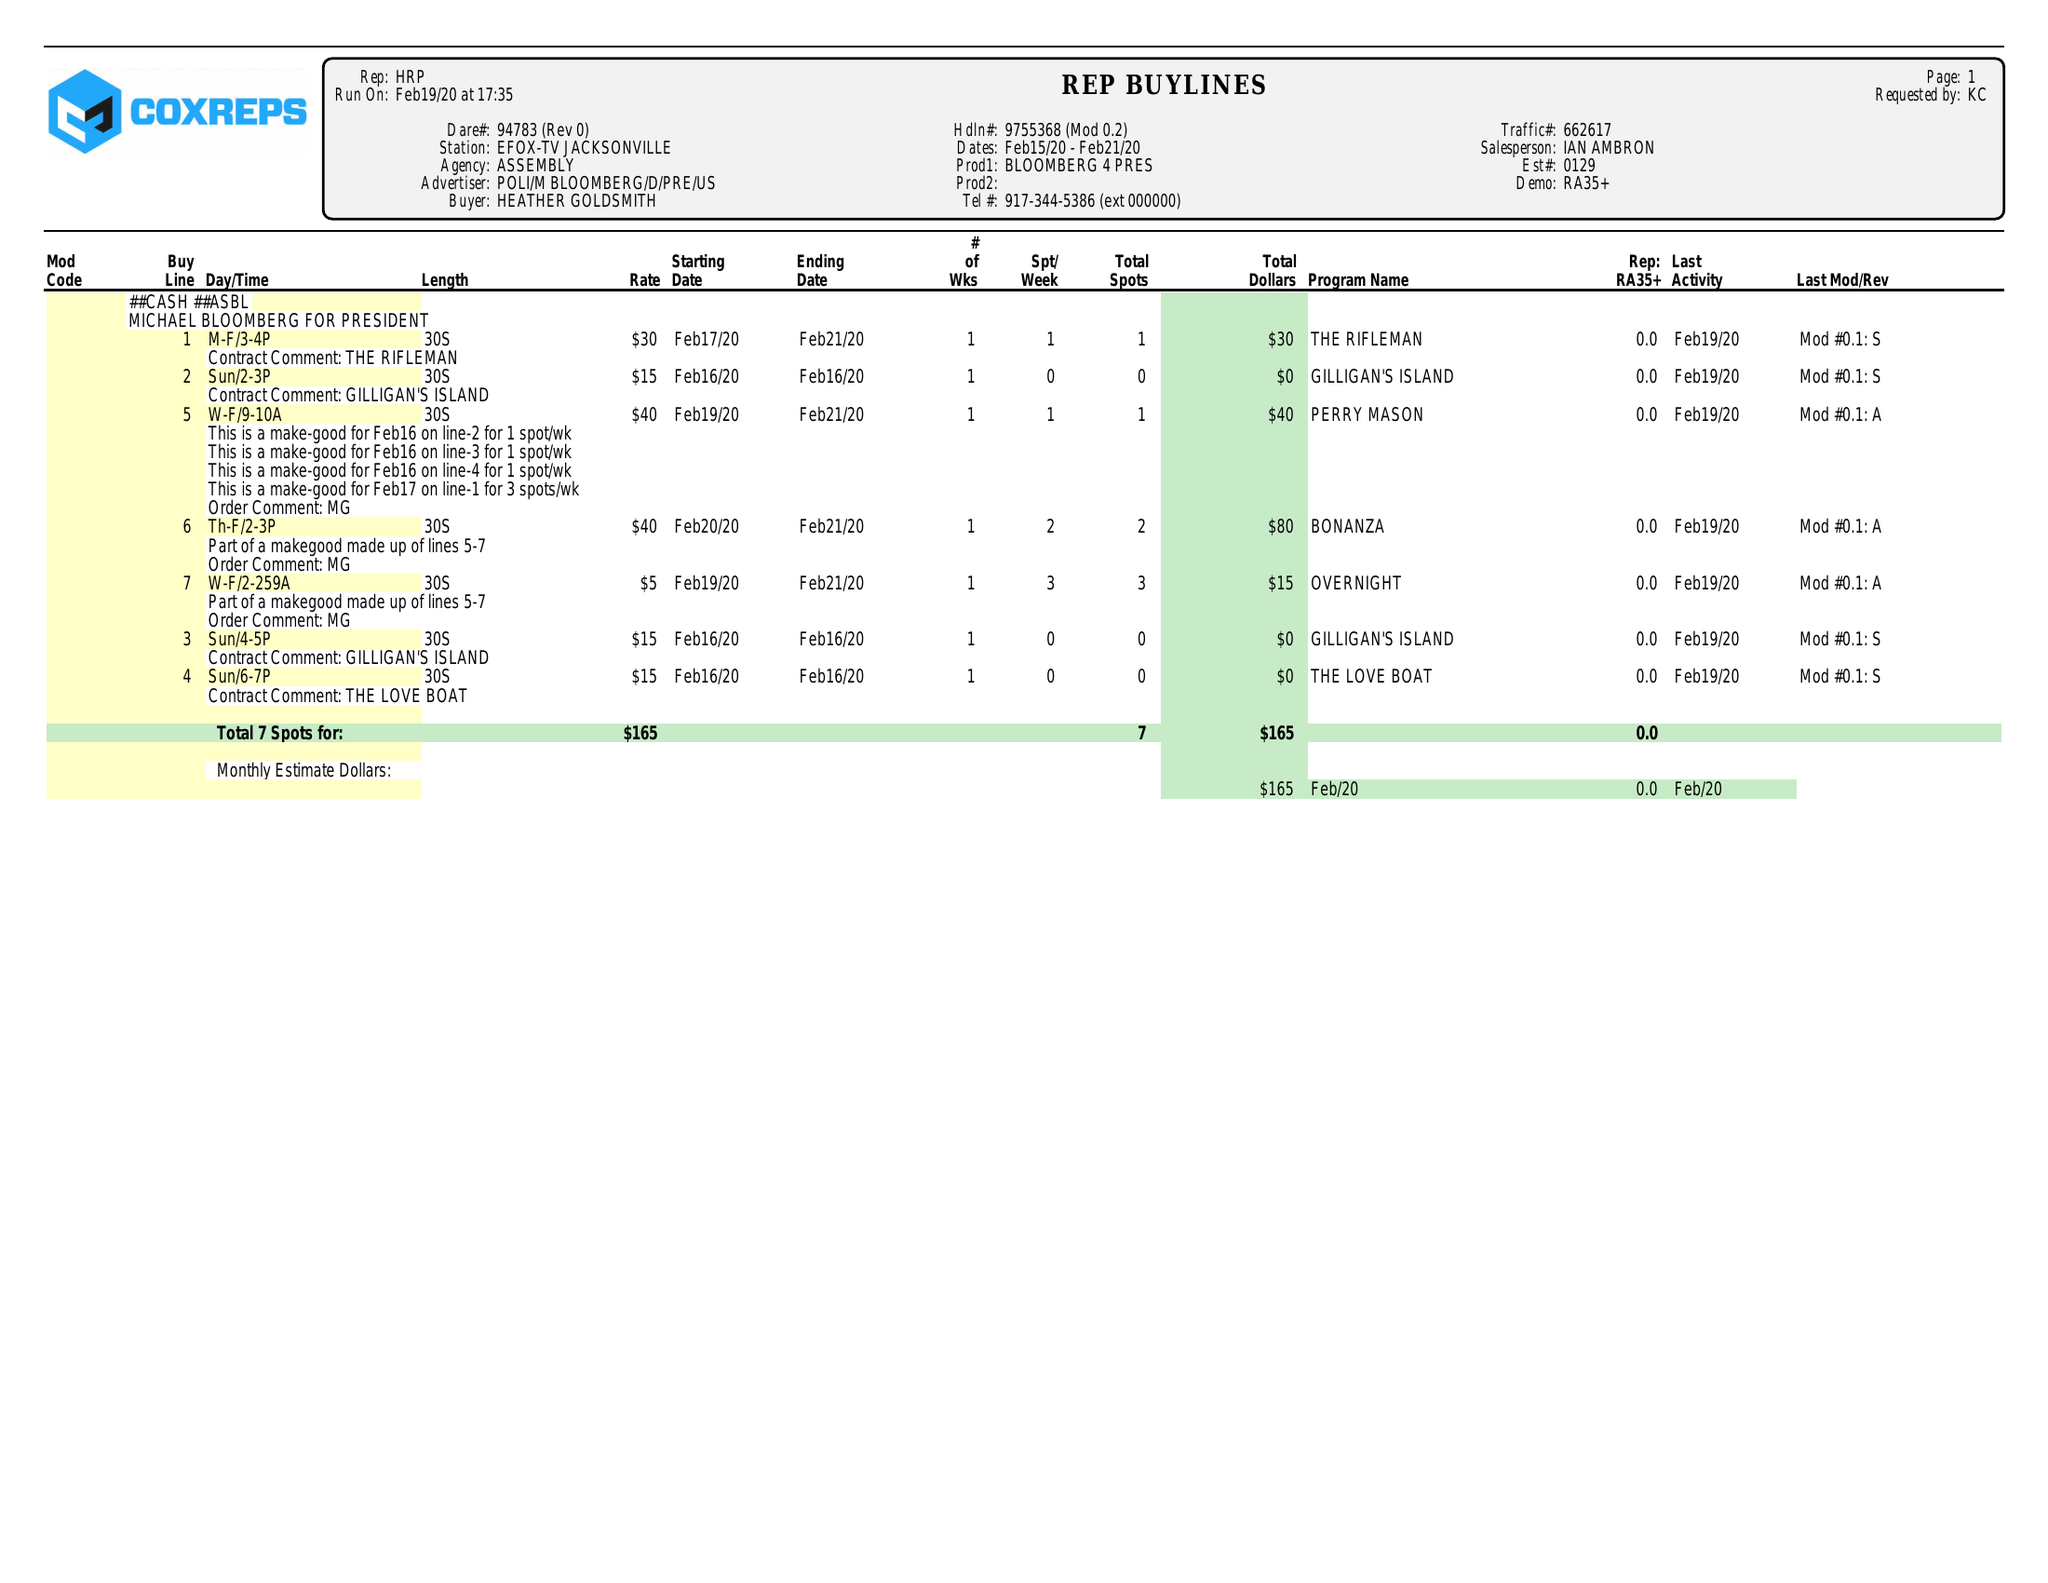What is the value for the contract_num?
Answer the question using a single word or phrase. 94783 